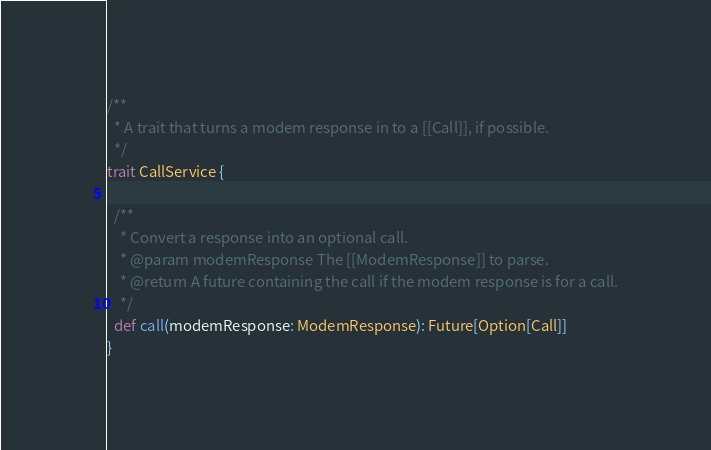Convert code to text. <code><loc_0><loc_0><loc_500><loc_500><_Scala_>
/**
  * A trait that turns a modem response in to a [[Call]], if possible.
  */
trait CallService {

  /**
    * Convert a response into an optional call.
    * @param modemResponse The [[ModemResponse]] to parse.
    * @return A future containing the call if the modem response is for a call.
    */
  def call(modemResponse: ModemResponse): Future[Option[Call]]
}
</code> 